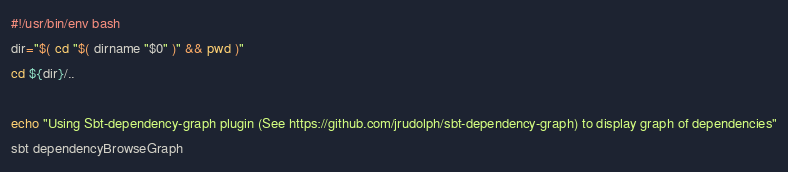<code> <loc_0><loc_0><loc_500><loc_500><_Bash_>#!/usr/bin/env bash
dir="$( cd "$( dirname "$0" )" && pwd )"
cd ${dir}/..

echo "Using Sbt-dependency-graph plugin (See https://github.com/jrudolph/sbt-dependency-graph) to display graph of dependencies"
sbt dependencyBrowseGraph</code> 